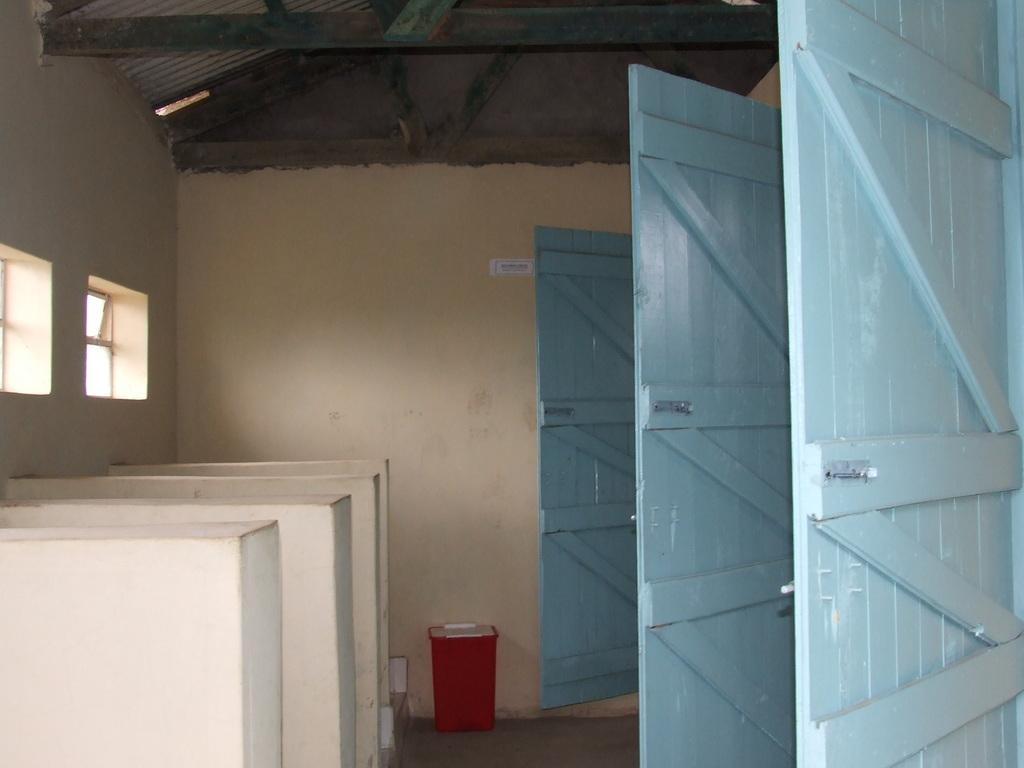What color are the wooden doors in the image? The wooden doors in the image are blue. What other object can be seen in the image that is a different color? There is a red color dustbin in the image. What type of air circulation system is present in the image? Ventilators are present in the image. What can be seen in the background of the image? There is a wall and the ceiling visible in the background of the image. What type of wound can be seen on the wall in the image? There is no wound present on the wall in the image. What type of jewel is placed on top of the dustbin in the image? There is no jewel present on top of the dustbin in the image. 